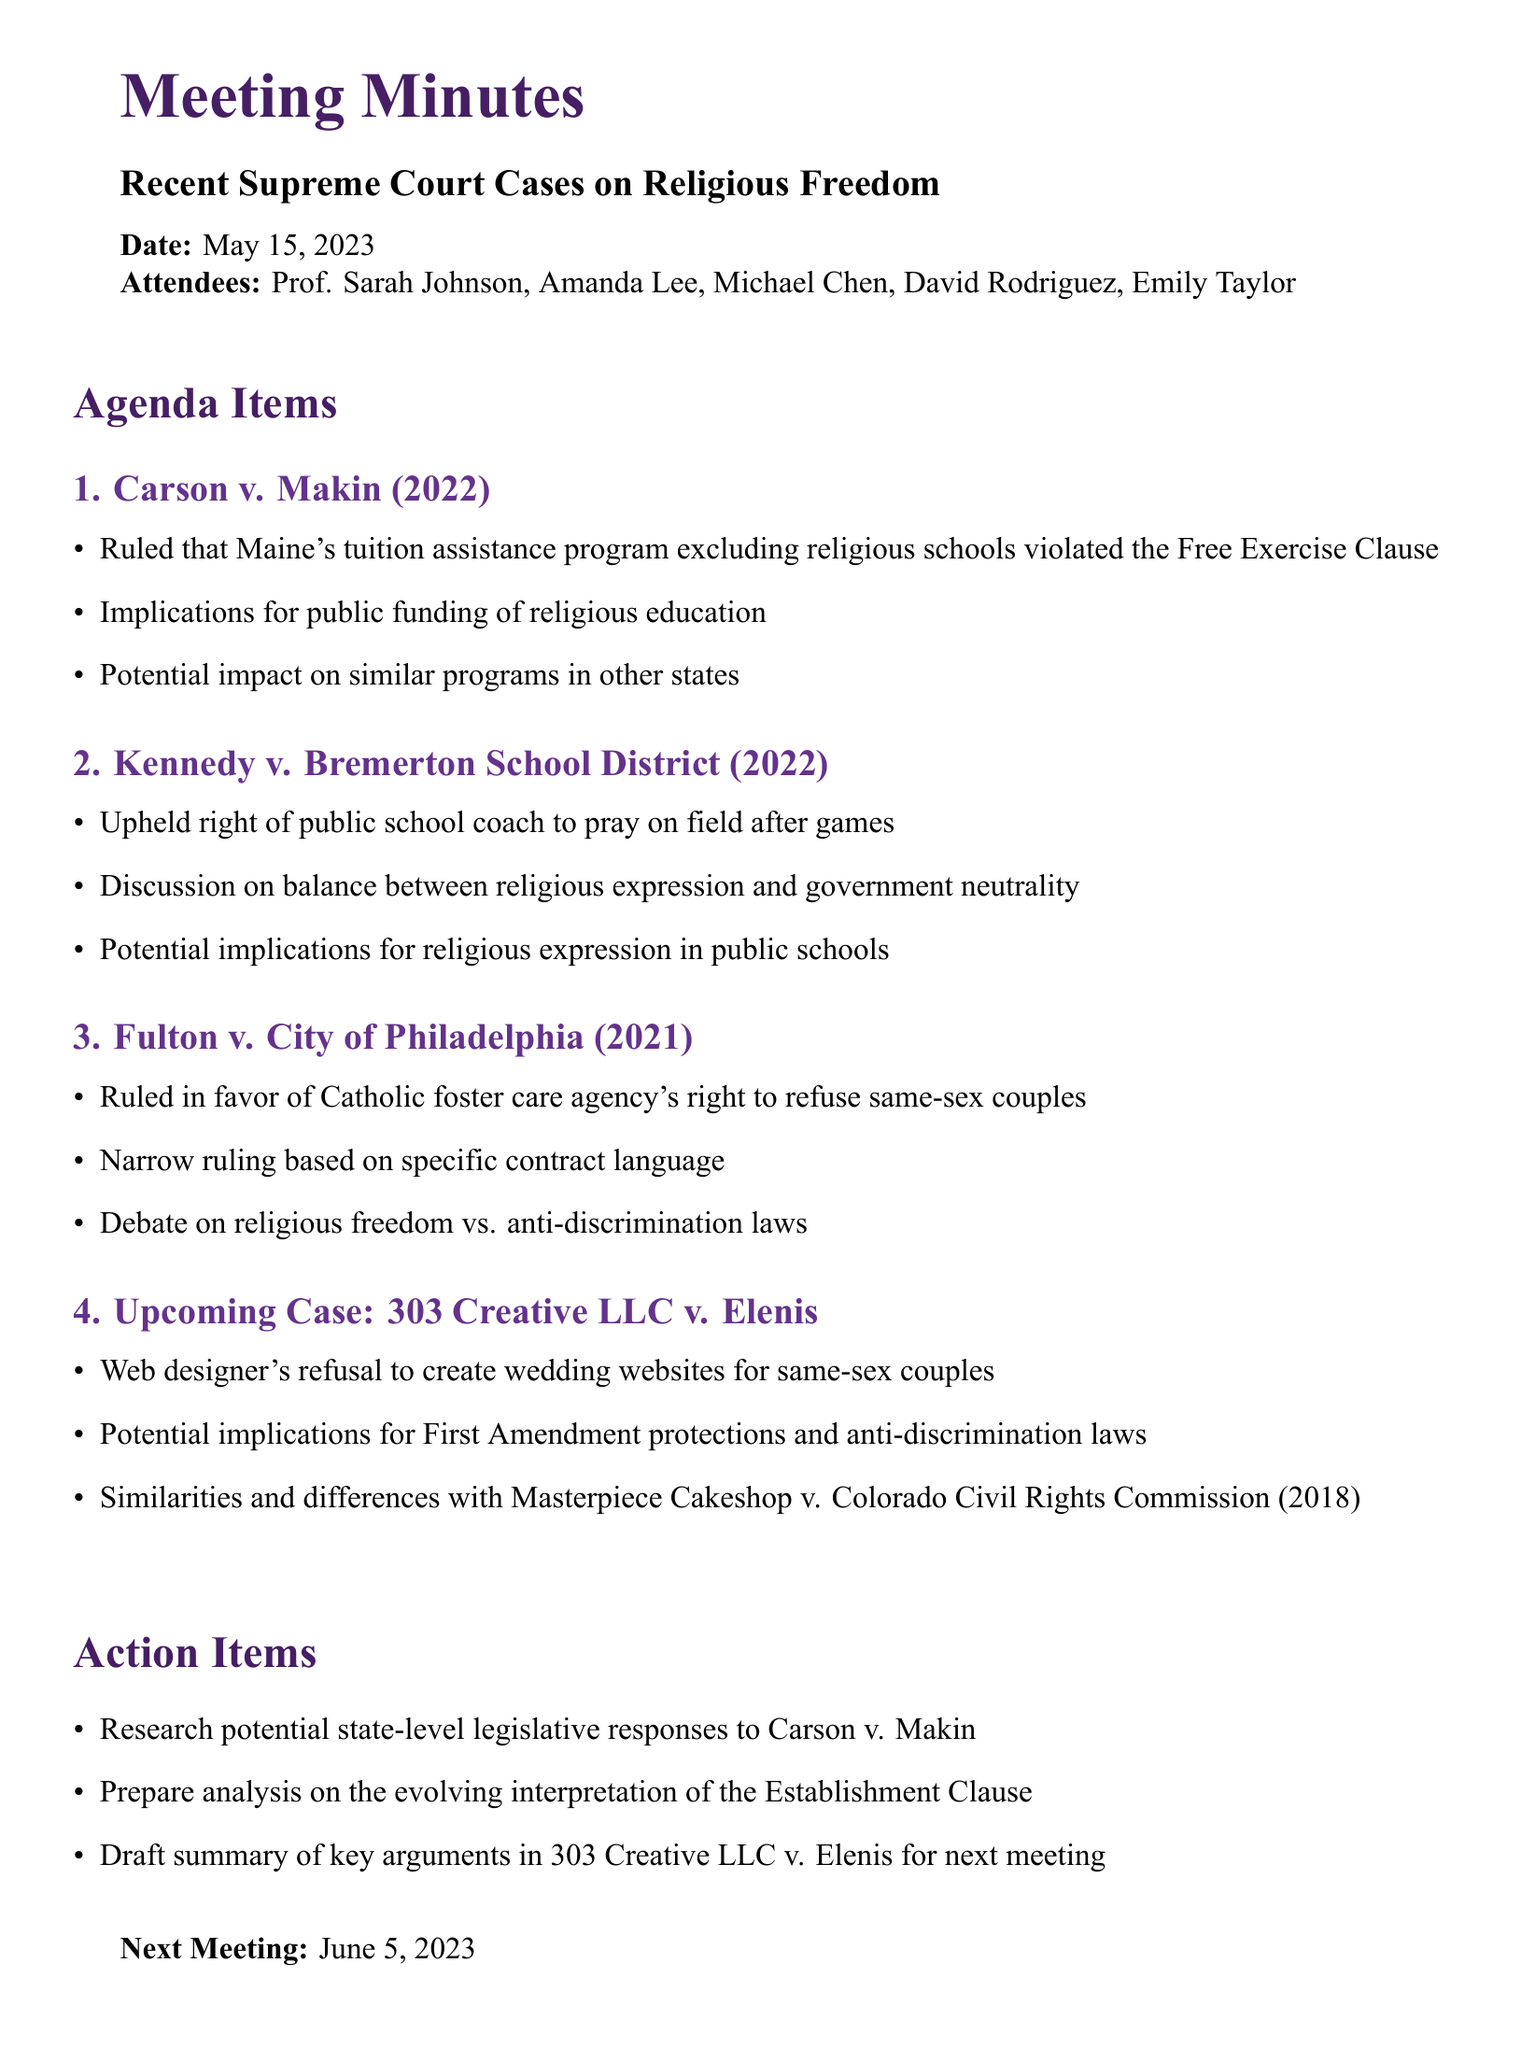What is the meeting title? The meeting title is explicitly stated at the beginning of the document, which is "Recent Supreme Court Cases on Religious Freedom."
Answer: Recent Supreme Court Cases on Religious Freedom When was the meeting held? The date of the meeting is clearly mentioned in the document as "May 15, 2023."
Answer: May 15, 2023 Who is one of the attendees? The attendees are listed in the document, and one name from the list is needed to answer the question.
Answer: Prof. Sarah Johnson What was ruled in Carson v. Makin (2022)? The key point from the case in the document specifies that Maine's tuition assistance program excluding religious schools violated the Free Exercise Clause.
Answer: Violated the Free Exercise Clause What is the implication of 303 Creative LLC v. Elenis? The document discusses the potential implications for First Amendment protections and anti-discrimination laws related to the case.
Answer: First Amendment protections and anti-discrimination laws What was the ruling in Fulton v. City of Philadelphia (2021)? The document notes that the court ruled in favor of the Catholic foster care agency's right to refuse same-sex couples.
Answer: Favor of Catholic foster care agency What is the next meeting date? The document indicates when the next meeting is scheduled to take place, providing a clear answer.
Answer: June 5, 2023 What action item involves researching responses to a court case? The action items specifically mention researching potential state-level legislative responses to Carson v. Makin.
Answer: Research potential state-level legislative responses to Carson v. Makin How many agenda items were discussed? The number of agenda items can be counted as they are listed in the document.
Answer: Four 